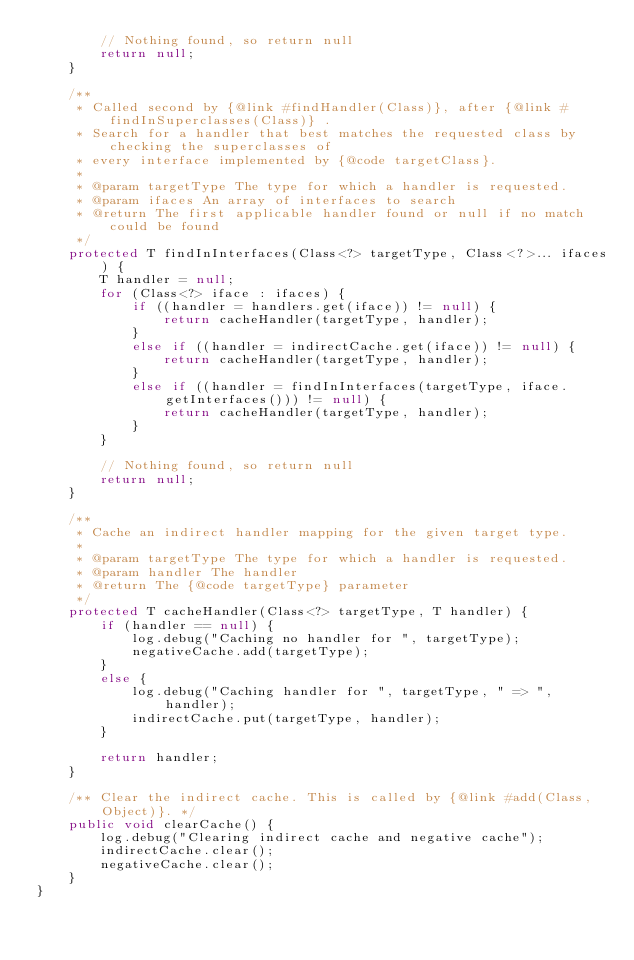Convert code to text. <code><loc_0><loc_0><loc_500><loc_500><_Java_>        // Nothing found, so return null
        return null;
    }

    /**
     * Called second by {@link #findHandler(Class)}, after {@link #findInSuperclasses(Class)} .
     * Search for a handler that best matches the requested class by checking the superclasses of
     * every interface implemented by {@code targetClass}.
     * 
     * @param targetType The type for which a handler is requested.
     * @param ifaces An array of interfaces to search
     * @return The first applicable handler found or null if no match could be found
     */
    protected T findInInterfaces(Class<?> targetType, Class<?>... ifaces) {
        T handler = null;
        for (Class<?> iface : ifaces) {
            if ((handler = handlers.get(iface)) != null) {
                return cacheHandler(targetType, handler);
            }
            else if ((handler = indirectCache.get(iface)) != null) {
                return cacheHandler(targetType, handler);
            }
            else if ((handler = findInInterfaces(targetType, iface.getInterfaces())) != null) {
                return cacheHandler(targetType, handler);
            }
        }

        // Nothing found, so return null
        return null;
    }

    /**
     * Cache an indirect handler mapping for the given target type.
     * 
     * @param targetType The type for which a handler is requested.
     * @param handler The handler
     * @return The {@code targetType} parameter
     */
    protected T cacheHandler(Class<?> targetType, T handler) {
        if (handler == null) {
            log.debug("Caching no handler for ", targetType);
            negativeCache.add(targetType);
        }
        else {
            log.debug("Caching handler for ", targetType, " => ", handler);
            indirectCache.put(targetType, handler);
        }

        return handler;
    }

    /** Clear the indirect cache. This is called by {@link #add(Class, Object)}. */
    public void clearCache() {
        log.debug("Clearing indirect cache and negative cache");
        indirectCache.clear();
        negativeCache.clear();
    }
}
</code> 